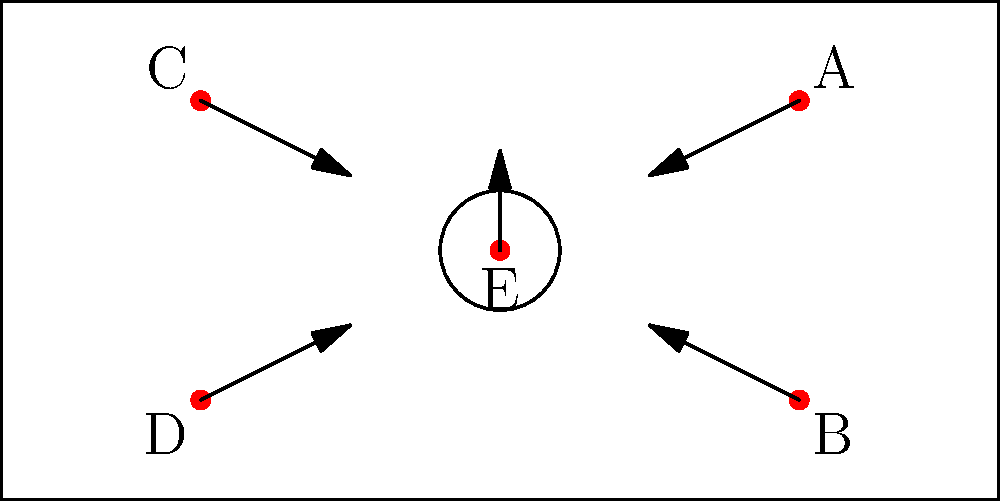As a basketball trainer, you're designing a defensive formation. Five players (A, B, C, D, and E) are positioned on the court as shown. If the opposing team's strongest shooter is at the top of the key, which player should move to defend them, and how should the remaining players adjust their positions to maintain optimal court coverage? To solve this spatial puzzle, let's break it down step-by-step:

1. Identify the current positions:
   - Player A: Top right corner
   - Player B: Bottom right corner
   - Player C: Top left corner
   - Player D: Bottom left corner
   - Player E: Center of the court

2. Analyze the situation:
   - The opposing team's strongest shooter is at the top of the key (just beyond the free-throw line).
   - We need to defend this player while maintaining overall court coverage.

3. Choose the defender:
   - Player E is in the best position to defend the shooter as they are already at the center of the court.
   - Moving E to the top of the key requires the least movement and maintains the overall defensive structure.

4. Adjust remaining players:
   - With E moving up, we need to cover the space they leave behind.
   - Players A and C should move slightly inward and down to cover the wings and provide help defense.
   - Players B and D should move slightly inward to protect the paint and be ready to help on drives.

5. Final formation:
   - E moves to the top of the key to defend the shooter.
   - A shifts to about halfway between their original position and the right elbow.
   - C shifts to about halfway between their original position and the left elbow.
   - B moves slightly inward, staying in the right corner but closer to the paint.
   - D moves slightly inward, staying in the left corner but closer to the paint.

This formation creates a diamond shape with E at the top, A and C forming the sides, and B and D forming the base. This provides optimal court coverage while addressing the immediate threat of the strong shooter.
Answer: E defends; A and C shift inward and down; B and D move slightly inward. 